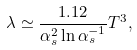<formula> <loc_0><loc_0><loc_500><loc_500>\lambda \simeq \frac { 1 . 1 2 } { \alpha _ { s } ^ { 2 } \ln \alpha _ { s } ^ { - 1 } } T ^ { 3 } ,</formula> 